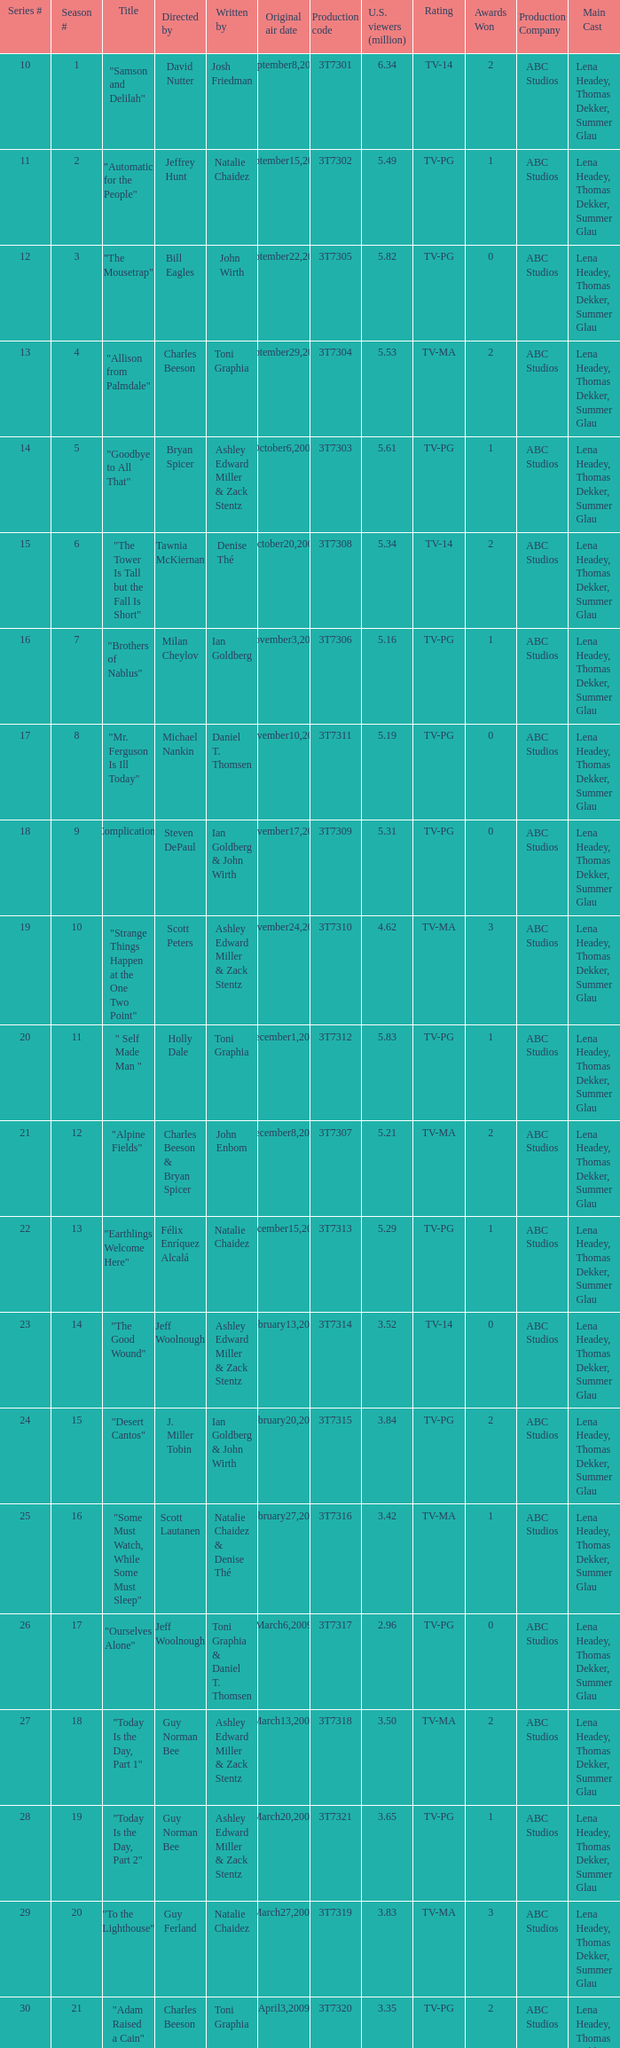Which episode number was directed by Bill Eagles? 12.0. 